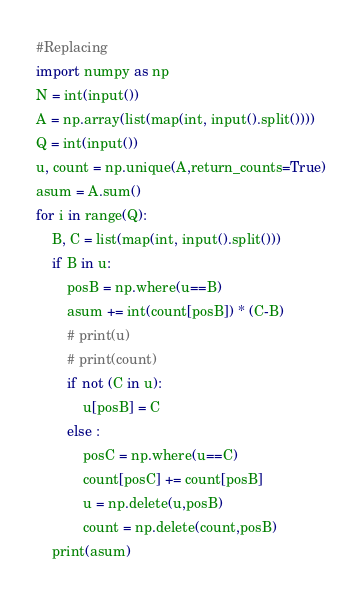Convert code to text. <code><loc_0><loc_0><loc_500><loc_500><_Python_>#Replacing
import numpy as np
N = int(input())
A = np.array(list(map(int, input().split())))
Q = int(input())
u, count = np.unique(A,return_counts=True)
asum = A.sum()
for i in range(Q):
    B, C = list(map(int, input().split()))
    if B in u:
        posB = np.where(u==B)
        asum += int(count[posB]) * (C-B)
        # print(u)
        # print(count)
        if not (C in u):
            u[posB] = C
        else :
            posC = np.where(u==C)
            count[posC] += count[posB]
            u = np.delete(u,posB)
            count = np.delete(count,posB)
    print(asum)

</code> 